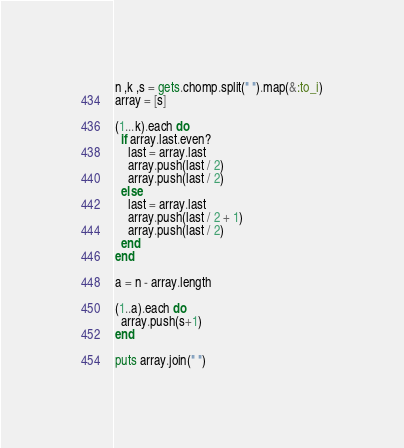<code> <loc_0><loc_0><loc_500><loc_500><_Ruby_>n ,k ,s = gets.chomp.split(" ").map(&:to_i)
array = [s]

(1...k).each do
  if array.last.even?
    last = array.last 
    array.push(last / 2)
    array.push(last / 2)
  else
    last = array.last
    array.push(last / 2 + 1)
    array.push(last / 2)
  end
end

a = n - array.length

(1..a).each do
  array.push(s+1)
end

puts array.join(" ")


</code> 